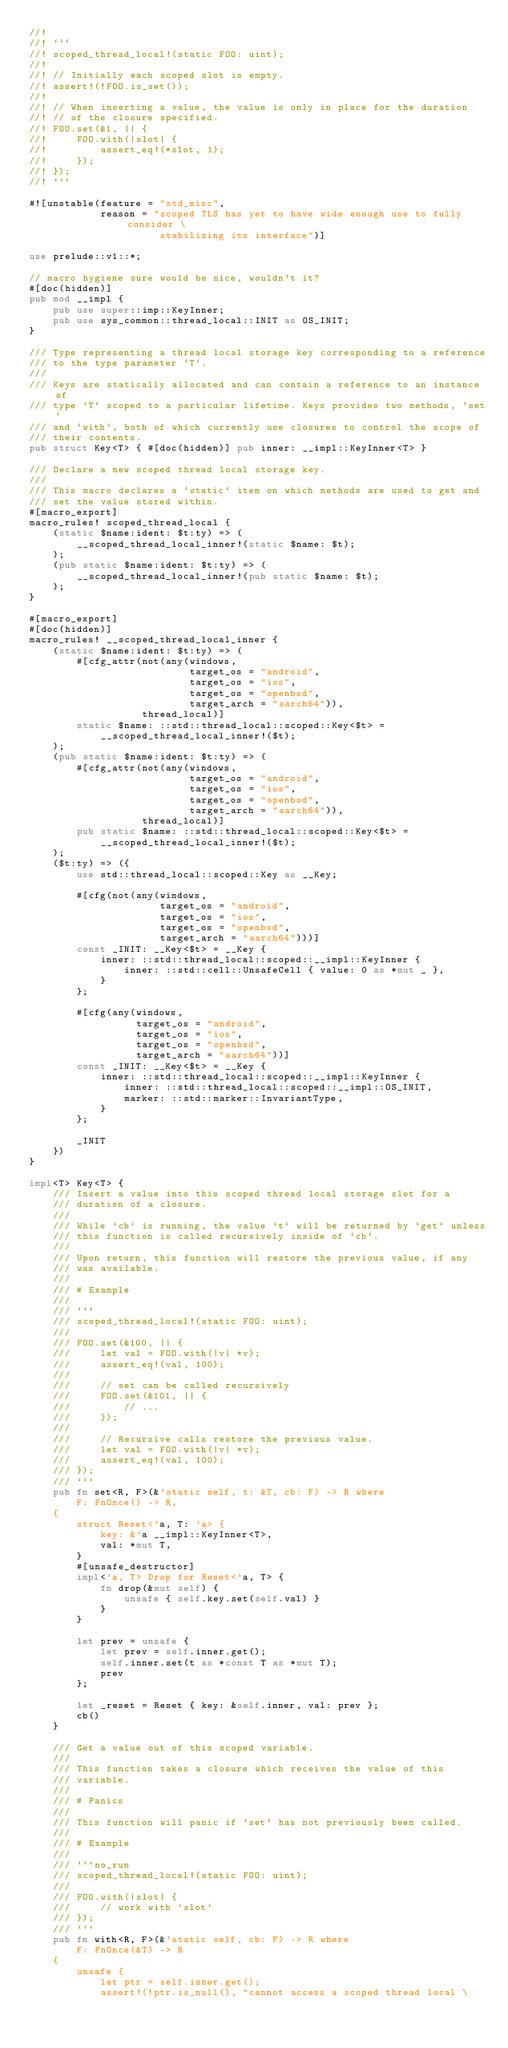Convert code to text. <code><loc_0><loc_0><loc_500><loc_500><_Rust_>//!
//! ```
//! scoped_thread_local!(static FOO: uint);
//!
//! // Initially each scoped slot is empty.
//! assert!(!FOO.is_set());
//!
//! // When inserting a value, the value is only in place for the duration
//! // of the closure specified.
//! FOO.set(&1, || {
//!     FOO.with(|slot| {
//!         assert_eq!(*slot, 1);
//!     });
//! });
//! ```

#![unstable(feature = "std_misc",
            reason = "scoped TLS has yet to have wide enough use to fully consider \
                      stabilizing its interface")]

use prelude::v1::*;

// macro hygiene sure would be nice, wouldn't it?
#[doc(hidden)]
pub mod __impl {
    pub use super::imp::KeyInner;
    pub use sys_common::thread_local::INIT as OS_INIT;
}

/// Type representing a thread local storage key corresponding to a reference
/// to the type parameter `T`.
///
/// Keys are statically allocated and can contain a reference to an instance of
/// type `T` scoped to a particular lifetime. Keys provides two methods, `set`
/// and `with`, both of which currently use closures to control the scope of
/// their contents.
pub struct Key<T> { #[doc(hidden)] pub inner: __impl::KeyInner<T> }

/// Declare a new scoped thread local storage key.
///
/// This macro declares a `static` item on which methods are used to get and
/// set the value stored within.
#[macro_export]
macro_rules! scoped_thread_local {
    (static $name:ident: $t:ty) => (
        __scoped_thread_local_inner!(static $name: $t);
    );
    (pub static $name:ident: $t:ty) => (
        __scoped_thread_local_inner!(pub static $name: $t);
    );
}

#[macro_export]
#[doc(hidden)]
macro_rules! __scoped_thread_local_inner {
    (static $name:ident: $t:ty) => (
        #[cfg_attr(not(any(windows,
                           target_os = "android",
                           target_os = "ios",
                           target_os = "openbsd",
                           target_arch = "aarch64")),
                   thread_local)]
        static $name: ::std::thread_local::scoped::Key<$t> =
            __scoped_thread_local_inner!($t);
    );
    (pub static $name:ident: $t:ty) => (
        #[cfg_attr(not(any(windows,
                           target_os = "android",
                           target_os = "ios",
                           target_os = "openbsd",
                           target_arch = "aarch64")),
                   thread_local)]
        pub static $name: ::std::thread_local::scoped::Key<$t> =
            __scoped_thread_local_inner!($t);
    );
    ($t:ty) => ({
        use std::thread_local::scoped::Key as __Key;

        #[cfg(not(any(windows,
                      target_os = "android",
                      target_os = "ios",
                      target_os = "openbsd",
                      target_arch = "aarch64")))]
        const _INIT: __Key<$t> = __Key {
            inner: ::std::thread_local::scoped::__impl::KeyInner {
                inner: ::std::cell::UnsafeCell { value: 0 as *mut _ },
            }
        };

        #[cfg(any(windows,
                  target_os = "android",
                  target_os = "ios",
                  target_os = "openbsd",
                  target_arch = "aarch64"))]
        const _INIT: __Key<$t> = __Key {
            inner: ::std::thread_local::scoped::__impl::KeyInner {
                inner: ::std::thread_local::scoped::__impl::OS_INIT,
                marker: ::std::marker::InvariantType,
            }
        };

        _INIT
    })
}

impl<T> Key<T> {
    /// Insert a value into this scoped thread local storage slot for a
    /// duration of a closure.
    ///
    /// While `cb` is running, the value `t` will be returned by `get` unless
    /// this function is called recursively inside of `cb`.
    ///
    /// Upon return, this function will restore the previous value, if any
    /// was available.
    ///
    /// # Example
    ///
    /// ```
    /// scoped_thread_local!(static FOO: uint);
    ///
    /// FOO.set(&100, || {
    ///     let val = FOO.with(|v| *v);
    ///     assert_eq!(val, 100);
    ///
    ///     // set can be called recursively
    ///     FOO.set(&101, || {
    ///         // ...
    ///     });
    ///
    ///     // Recursive calls restore the previous value.
    ///     let val = FOO.with(|v| *v);
    ///     assert_eq!(val, 100);
    /// });
    /// ```
    pub fn set<R, F>(&'static self, t: &T, cb: F) -> R where
        F: FnOnce() -> R,
    {
        struct Reset<'a, T: 'a> {
            key: &'a __impl::KeyInner<T>,
            val: *mut T,
        }
        #[unsafe_destructor]
        impl<'a, T> Drop for Reset<'a, T> {
            fn drop(&mut self) {
                unsafe { self.key.set(self.val) }
            }
        }

        let prev = unsafe {
            let prev = self.inner.get();
            self.inner.set(t as *const T as *mut T);
            prev
        };

        let _reset = Reset { key: &self.inner, val: prev };
        cb()
    }

    /// Get a value out of this scoped variable.
    ///
    /// This function takes a closure which receives the value of this
    /// variable.
    ///
    /// # Panics
    ///
    /// This function will panic if `set` has not previously been called.
    ///
    /// # Example
    ///
    /// ```no_run
    /// scoped_thread_local!(static FOO: uint);
    ///
    /// FOO.with(|slot| {
    ///     // work with `slot`
    /// });
    /// ```
    pub fn with<R, F>(&'static self, cb: F) -> R where
        F: FnOnce(&T) -> R
    {
        unsafe {
            let ptr = self.inner.get();
            assert!(!ptr.is_null(), "cannot access a scoped thread local \</code> 